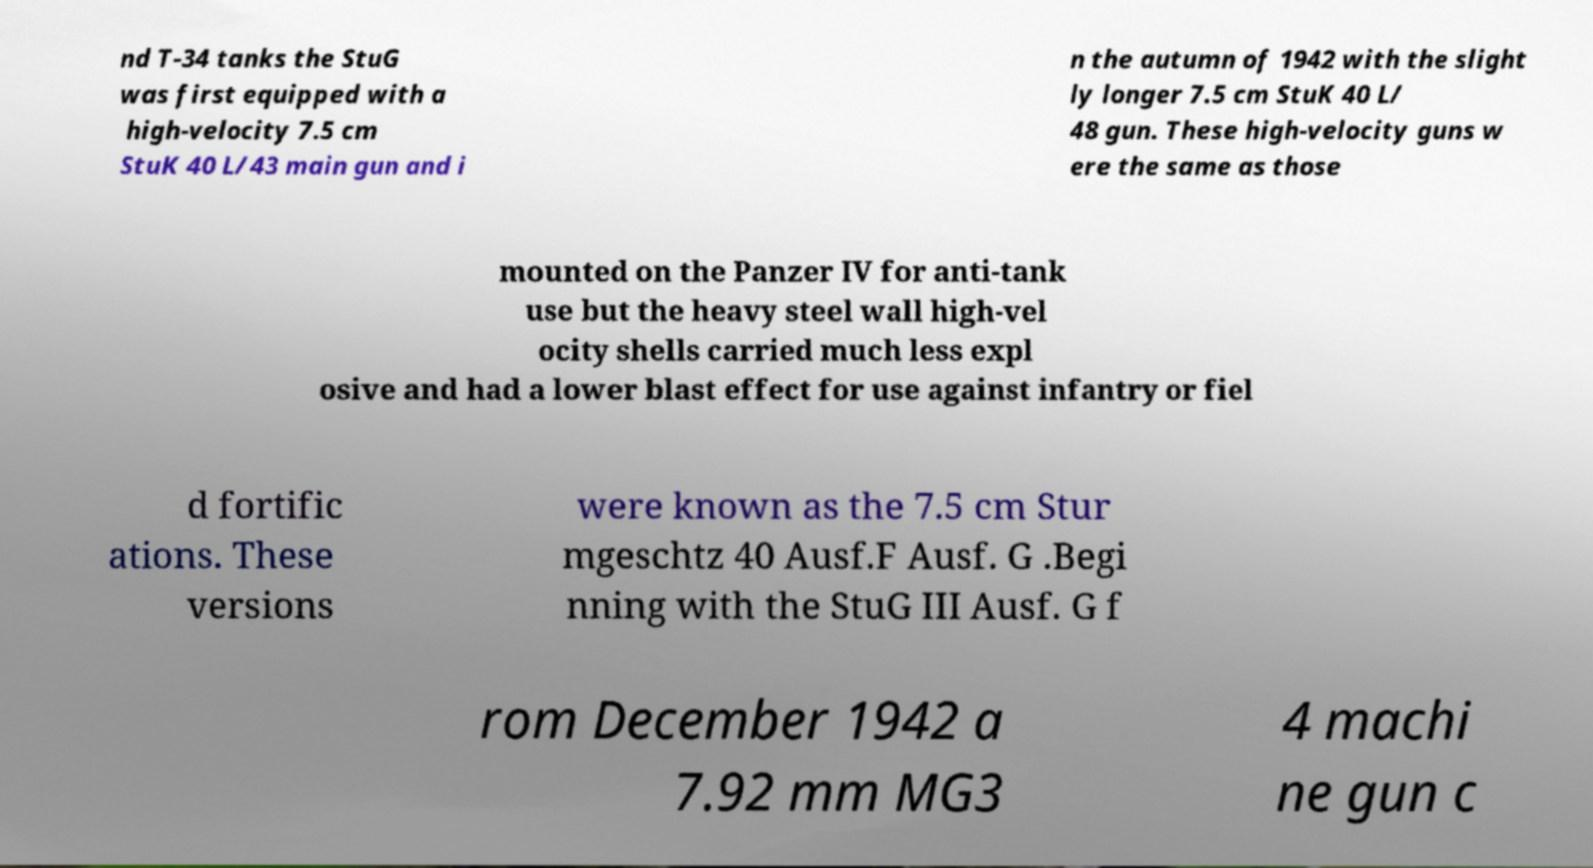Please identify and transcribe the text found in this image. nd T-34 tanks the StuG was first equipped with a high-velocity 7.5 cm StuK 40 L/43 main gun and i n the autumn of 1942 with the slight ly longer 7.5 cm StuK 40 L/ 48 gun. These high-velocity guns w ere the same as those mounted on the Panzer IV for anti-tank use but the heavy steel wall high-vel ocity shells carried much less expl osive and had a lower blast effect for use against infantry or fiel d fortific ations. These versions were known as the 7.5 cm Stur mgeschtz 40 Ausf.F Ausf. G .Begi nning with the StuG III Ausf. G f rom December 1942 a 7.92 mm MG3 4 machi ne gun c 